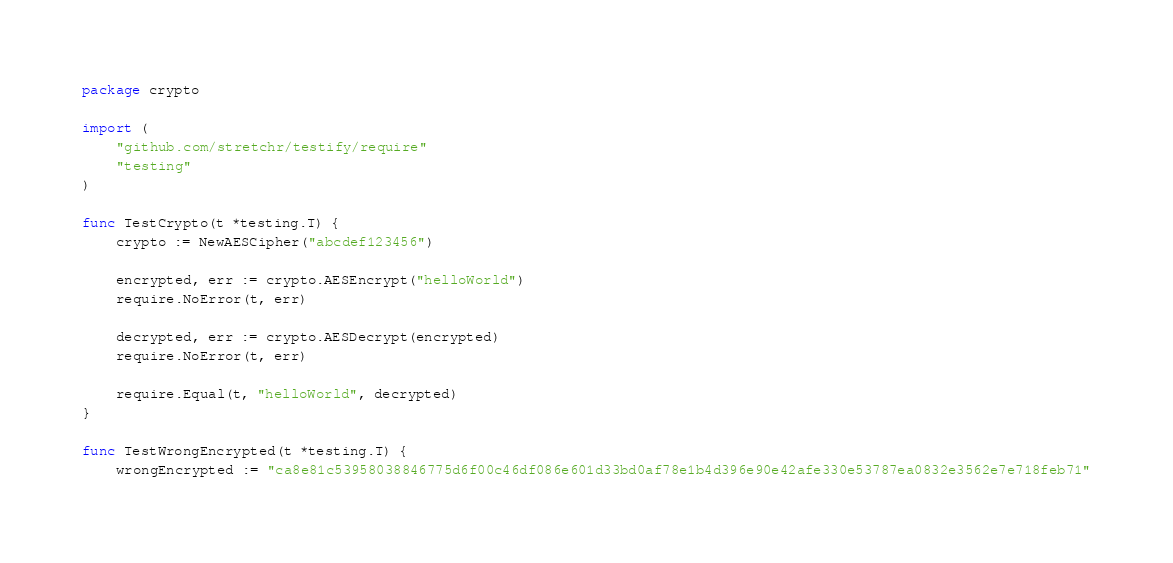Convert code to text. <code><loc_0><loc_0><loc_500><loc_500><_Go_>package crypto

import (
	"github.com/stretchr/testify/require"
	"testing"
)

func TestCrypto(t *testing.T) {
	crypto := NewAESCipher("abcdef123456")

	encrypted, err := crypto.AESEncrypt("helloWorld")
	require.NoError(t, err)

	decrypted, err := crypto.AESDecrypt(encrypted)
	require.NoError(t, err)

	require.Equal(t, "helloWorld", decrypted)
}

func TestWrongEncrypted(t *testing.T) {
	wrongEncrypted := "ca8e81c53958038846775d6f00c46df086e601d33bd0af78e1b4d396e90e42afe330e53787ea0832e3562e7e718feb71"</code> 